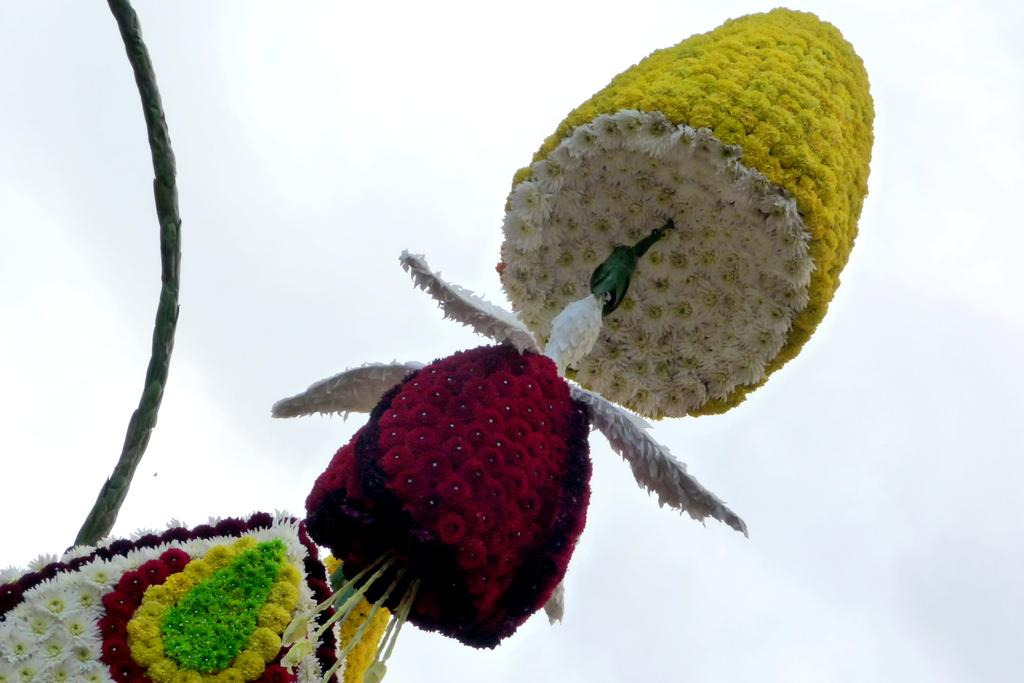What type of living organisms can be seen in the image? There are flowers in the image. What colors are the flowers in the image? The flowers are white, yellow, green, and red in color. What can be seen in the background of the image? The sky is visible in the background of the image. What is the condition of the sky in the image? The sky is clear in the image. What color is the green thing in the image? The green color thing in the image is not specified, but it is likely one of the flowers or a part of the flowers. Can you see an airplane flying in the sky in the image? No, there is no airplane visible in the image. Is there a maid holding a tray of oranges in the image? No, there is no maid or tray of oranges present in the image. 